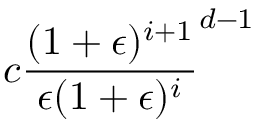Convert formula to latex. <formula><loc_0><loc_0><loc_500><loc_500>c { \frac { ( 1 + \epsilon ) ^ { i + 1 } } { \epsilon ( 1 + \epsilon ) ^ { i } } } ^ { d - 1 }</formula> 